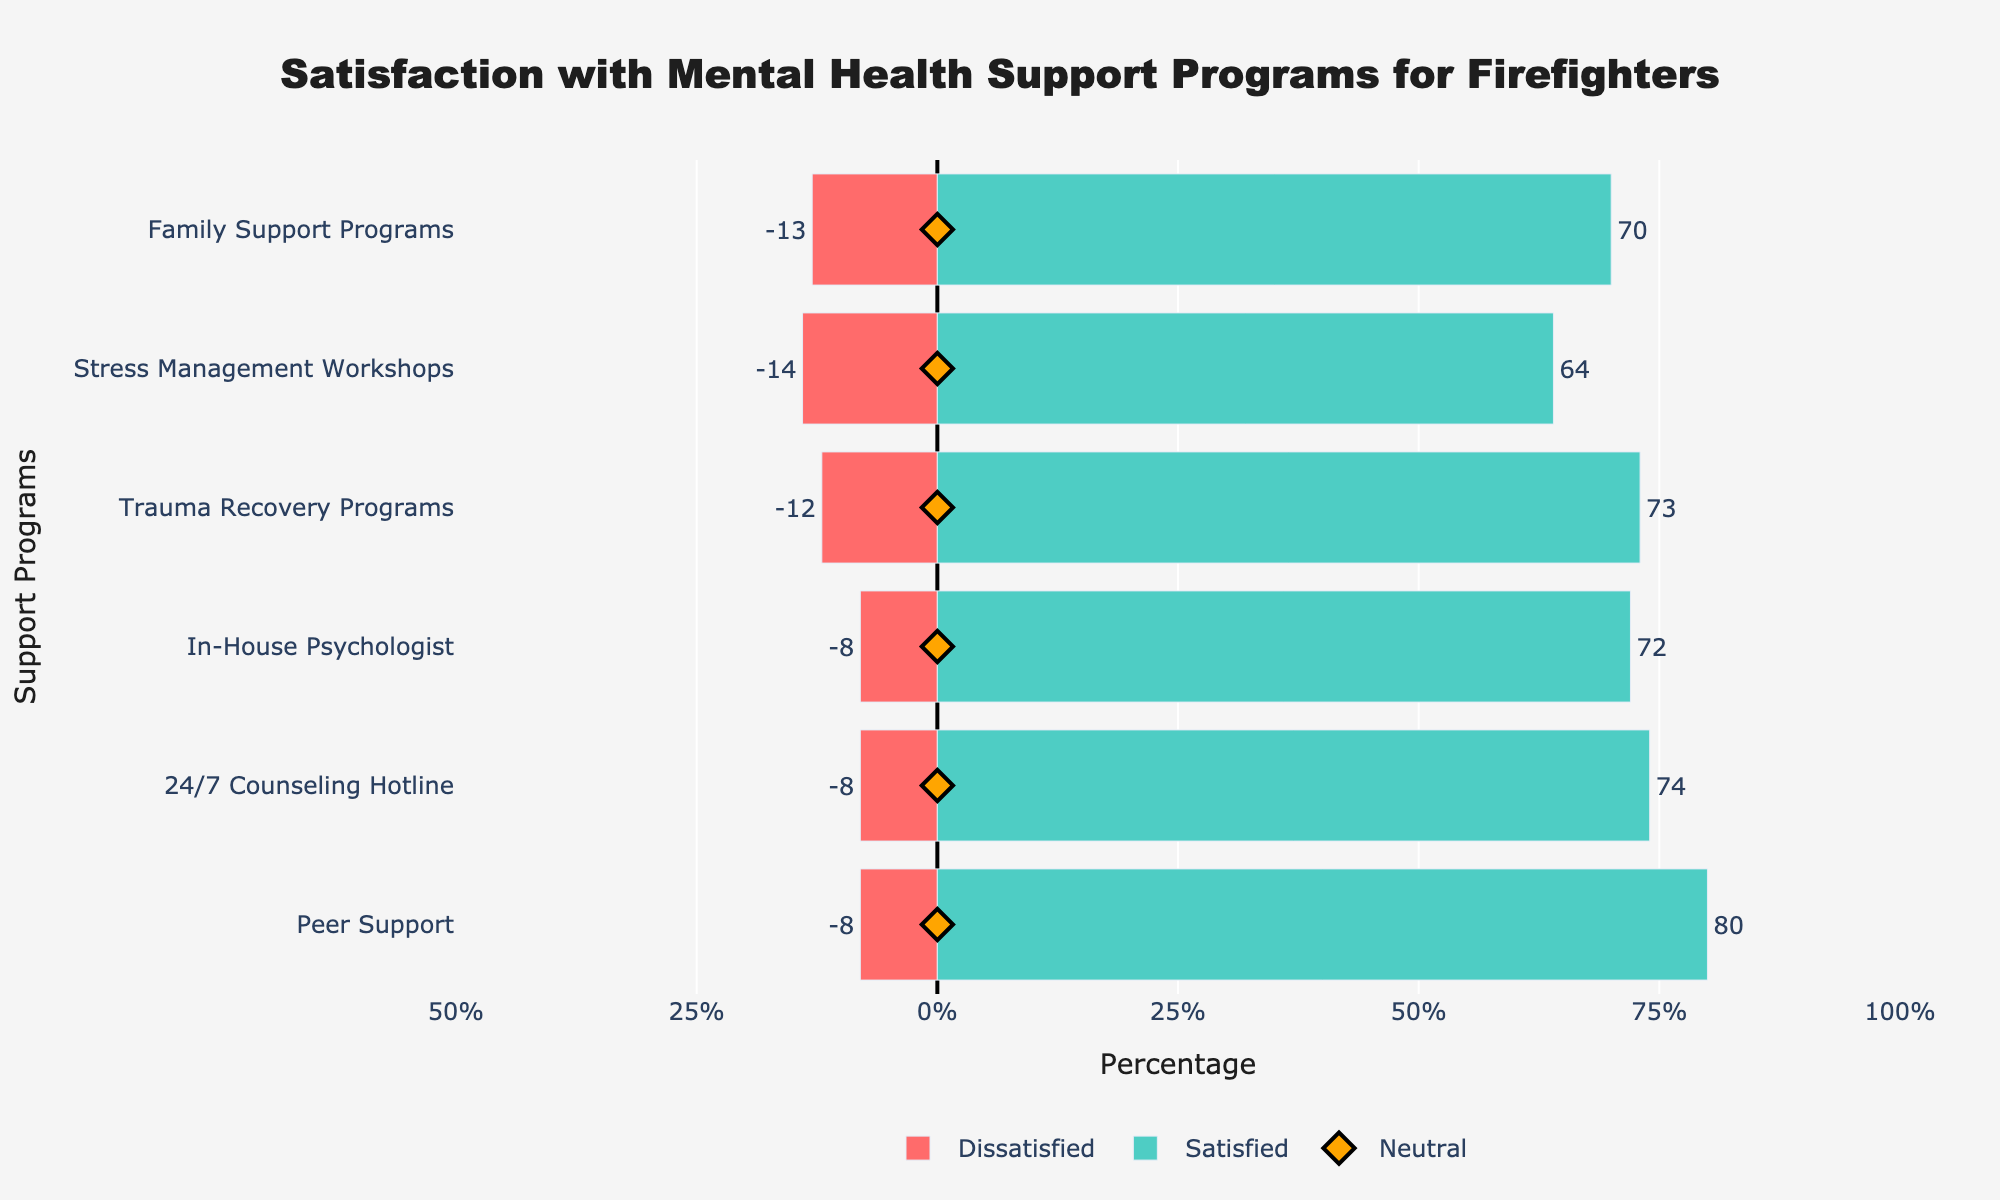Which program has the highest level of satisfaction? The program with the highest green bar that indicates positive satisfaction is Peer Support. The total positive satisfaction (Satisfied + Very Satisfied) for Peer Support is 80%.
Answer: Peer Support Which program has the highest level of dissatisfaction? The program with the longest red bar that indicates dissatisfaction is Family Support Programs. The total dissatisfaction (Very Dissatisfied + Dissatisfied) for Family Support Programs is 13%.
Answer: Family Support Programs How many programs have more than 70% satisfaction? Identify bars with green sections longer than 70% of the total length. Peer Support has 80%, 24/7 Counseling Hotline has 74%, In-House Psychologist has 72%, and Trauma Recovery Programs have 73%, totaling to 4 programs.
Answer: 4 What's the total neutral percentage across all programs? Sum the neutral percentages: 12 + 18 + 20 + 15 + 22 + 17 = 104%.
Answer: 104% Compare the satisfaction levels of Peer Support and Family Support Programs. Which one is higher and by how much? Peer Support has 80% positive satisfaction, and Family Support Programs has 70% positive satisfaction. So, Peer Support's satisfaction is higher by 10%.
Answer: Peer Support, 10% Which program has the smallest difference between positive and negative satisfaction rates? Compute the difference for each program. For example, Peer Support: 80% (positive) - 8% (negative) = 72%, 24/7 Counseling Hotline: 74% - 8% = 66%. The smallest difference is Family Support Programs: 70% - 13% = 57%.
Answer: Family Support Programs Which program has the highest neutral response rate? The program with the highest number in the scatter (diamond markers) is Stress Management Workshops with 22%.
Answer: Stress Management Workshops Order the programs from highest to lowest in terms of positive satisfaction. Sort programs by the length of the green bars: Peer Support (80%), Trauma Recovery Programs (73%), In-House Psychologist (72%), 24/7 Counseling Hotline (74%), Family Support Programs (70%), Stress Management Workshops (64%).
Answer: Peer Support, 24/7 Counseling Hotline, Trauma Recovery Programs, In-House Psychologist, Family Support Programs, Stress Management Workshops What is the average dissatisfaction rate across all programs? Sum the dissatisfaction rates and divide by the number of programs: (8 + 8 + 8 + 12 + 14 + 13)/6 = 10.5%.
Answer: 10.5% Compare the neutral responses between In-House Psychologist and 24/7 Counseling Hotline. Which one is higher and by how much? In-House Psychologist has 20% neutral, while 24/7 Counseling Hotline has 18%. In-House Psychologist has a higher neutral response by 2%.
Answer: In-House Psychologist, 2% 